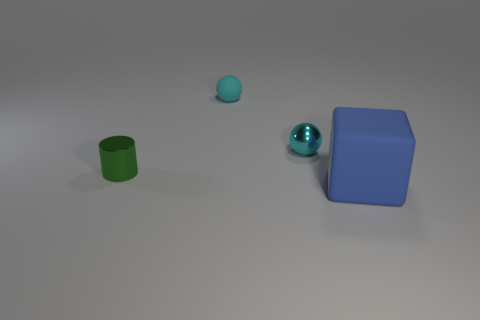Add 2 blue matte objects. How many objects exist? 6 Subtract all cylinders. How many objects are left? 3 Subtract 1 cylinders. How many cylinders are left? 0 Subtract 1 green cylinders. How many objects are left? 3 Subtract all yellow balls. Subtract all green blocks. How many balls are left? 2 Subtract all big red matte balls. Subtract all small cyan metal balls. How many objects are left? 3 Add 2 small cyan metallic things. How many small cyan metallic things are left? 3 Add 1 big blue spheres. How many big blue spheres exist? 1 